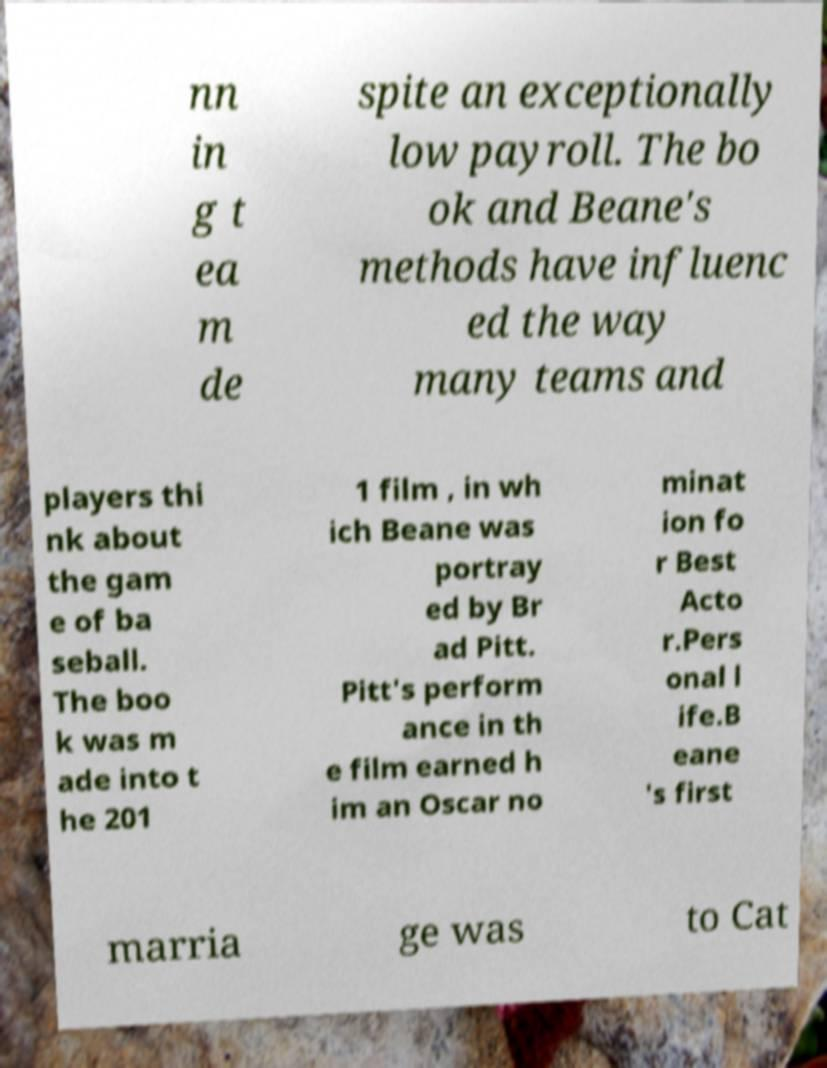Can you read and provide the text displayed in the image?This photo seems to have some interesting text. Can you extract and type it out for me? nn in g t ea m de spite an exceptionally low payroll. The bo ok and Beane's methods have influenc ed the way many teams and players thi nk about the gam e of ba seball. The boo k was m ade into t he 201 1 film , in wh ich Beane was portray ed by Br ad Pitt. Pitt's perform ance in th e film earned h im an Oscar no minat ion fo r Best Acto r.Pers onal l ife.B eane 's first marria ge was to Cat 